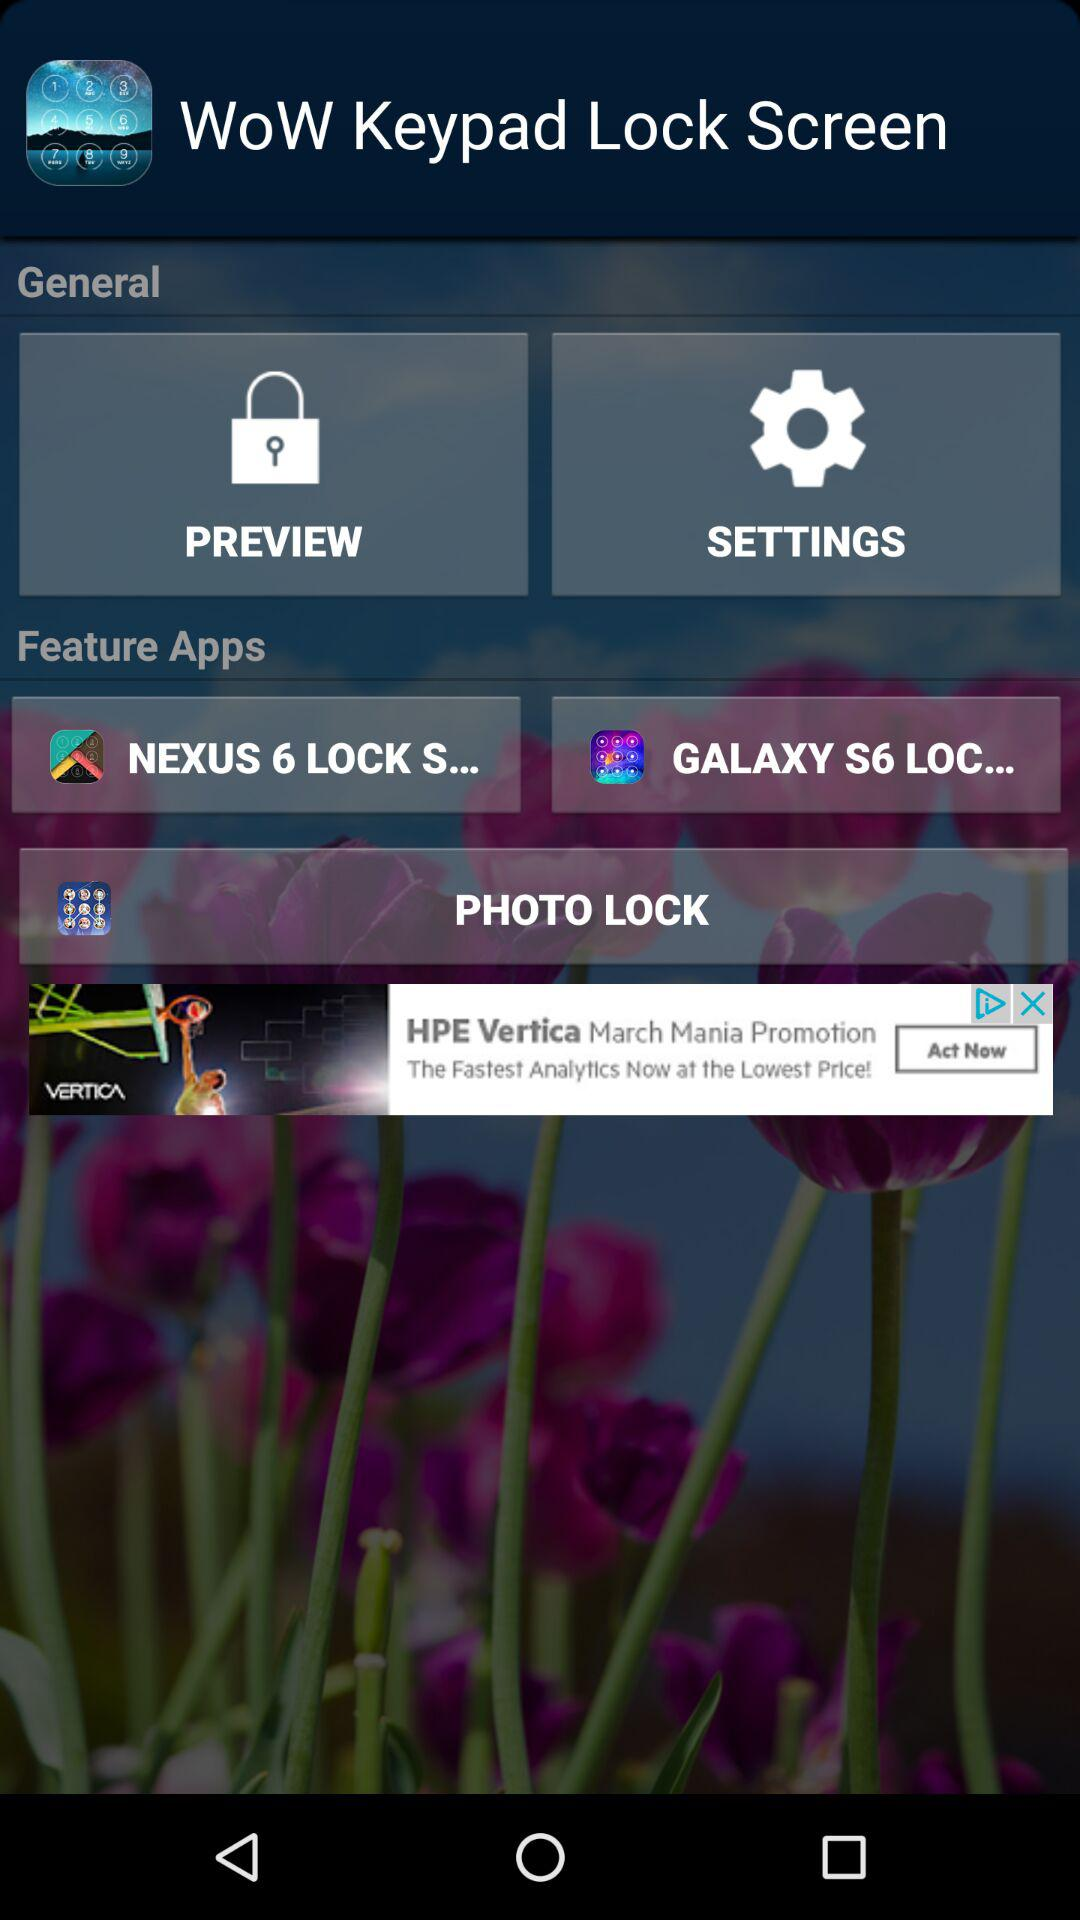Which are the featured apps? The featured apps are "NEXUS 6 LOCK S...", "GALAXY S6 LOC..." and "PHOTO LOCK". 